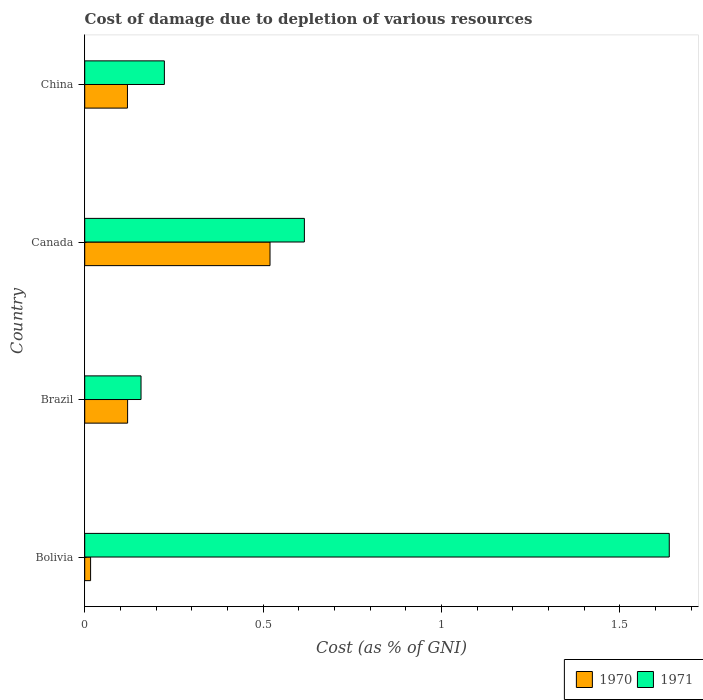How many different coloured bars are there?
Your response must be concise. 2. Are the number of bars per tick equal to the number of legend labels?
Keep it short and to the point. Yes. How many bars are there on the 2nd tick from the top?
Make the answer very short. 2. What is the cost of damage caused due to the depletion of various resources in 1971 in Brazil?
Provide a succinct answer. 0.16. Across all countries, what is the maximum cost of damage caused due to the depletion of various resources in 1970?
Your answer should be very brief. 0.52. Across all countries, what is the minimum cost of damage caused due to the depletion of various resources in 1971?
Offer a very short reply. 0.16. What is the total cost of damage caused due to the depletion of various resources in 1970 in the graph?
Offer a terse response. 0.78. What is the difference between the cost of damage caused due to the depletion of various resources in 1971 in Bolivia and that in China?
Provide a short and direct response. 1.42. What is the difference between the cost of damage caused due to the depletion of various resources in 1971 in China and the cost of damage caused due to the depletion of various resources in 1970 in Bolivia?
Give a very brief answer. 0.21. What is the average cost of damage caused due to the depletion of various resources in 1971 per country?
Make the answer very short. 0.66. What is the difference between the cost of damage caused due to the depletion of various resources in 1970 and cost of damage caused due to the depletion of various resources in 1971 in Brazil?
Your answer should be compact. -0.04. What is the ratio of the cost of damage caused due to the depletion of various resources in 1970 in Brazil to that in China?
Provide a succinct answer. 1. Is the cost of damage caused due to the depletion of various resources in 1971 in Bolivia less than that in China?
Make the answer very short. No. Is the difference between the cost of damage caused due to the depletion of various resources in 1970 in Bolivia and Brazil greater than the difference between the cost of damage caused due to the depletion of various resources in 1971 in Bolivia and Brazil?
Make the answer very short. No. What is the difference between the highest and the second highest cost of damage caused due to the depletion of various resources in 1970?
Your answer should be very brief. 0.4. What is the difference between the highest and the lowest cost of damage caused due to the depletion of various resources in 1971?
Provide a short and direct response. 1.48. What does the 2nd bar from the bottom in Brazil represents?
Keep it short and to the point. 1971. How many bars are there?
Your response must be concise. 8. What is the difference between two consecutive major ticks on the X-axis?
Keep it short and to the point. 0.5. Are the values on the major ticks of X-axis written in scientific E-notation?
Offer a terse response. No. How many legend labels are there?
Make the answer very short. 2. What is the title of the graph?
Keep it short and to the point. Cost of damage due to depletion of various resources. Does "1967" appear as one of the legend labels in the graph?
Ensure brevity in your answer.  No. What is the label or title of the X-axis?
Offer a terse response. Cost (as % of GNI). What is the label or title of the Y-axis?
Offer a terse response. Country. What is the Cost (as % of GNI) of 1970 in Bolivia?
Your answer should be very brief. 0.02. What is the Cost (as % of GNI) of 1971 in Bolivia?
Keep it short and to the point. 1.64. What is the Cost (as % of GNI) of 1970 in Brazil?
Provide a short and direct response. 0.12. What is the Cost (as % of GNI) of 1971 in Brazil?
Your answer should be compact. 0.16. What is the Cost (as % of GNI) of 1970 in Canada?
Your answer should be compact. 0.52. What is the Cost (as % of GNI) in 1971 in Canada?
Offer a very short reply. 0.62. What is the Cost (as % of GNI) in 1970 in China?
Give a very brief answer. 0.12. What is the Cost (as % of GNI) of 1971 in China?
Provide a succinct answer. 0.22. Across all countries, what is the maximum Cost (as % of GNI) of 1970?
Ensure brevity in your answer.  0.52. Across all countries, what is the maximum Cost (as % of GNI) of 1971?
Your response must be concise. 1.64. Across all countries, what is the minimum Cost (as % of GNI) in 1970?
Provide a short and direct response. 0.02. Across all countries, what is the minimum Cost (as % of GNI) in 1971?
Offer a very short reply. 0.16. What is the total Cost (as % of GNI) in 1970 in the graph?
Make the answer very short. 0.78. What is the total Cost (as % of GNI) of 1971 in the graph?
Offer a very short reply. 2.64. What is the difference between the Cost (as % of GNI) in 1970 in Bolivia and that in Brazil?
Your answer should be very brief. -0.1. What is the difference between the Cost (as % of GNI) in 1971 in Bolivia and that in Brazil?
Ensure brevity in your answer.  1.48. What is the difference between the Cost (as % of GNI) in 1970 in Bolivia and that in Canada?
Provide a short and direct response. -0.5. What is the difference between the Cost (as % of GNI) of 1971 in Bolivia and that in Canada?
Provide a short and direct response. 1.02. What is the difference between the Cost (as % of GNI) in 1970 in Bolivia and that in China?
Ensure brevity in your answer.  -0.1. What is the difference between the Cost (as % of GNI) of 1971 in Bolivia and that in China?
Your response must be concise. 1.42. What is the difference between the Cost (as % of GNI) of 1970 in Brazil and that in Canada?
Your answer should be very brief. -0.4. What is the difference between the Cost (as % of GNI) in 1971 in Brazil and that in Canada?
Give a very brief answer. -0.46. What is the difference between the Cost (as % of GNI) in 1970 in Brazil and that in China?
Your answer should be very brief. 0. What is the difference between the Cost (as % of GNI) of 1971 in Brazil and that in China?
Your answer should be very brief. -0.07. What is the difference between the Cost (as % of GNI) of 1970 in Canada and that in China?
Give a very brief answer. 0.4. What is the difference between the Cost (as % of GNI) of 1971 in Canada and that in China?
Keep it short and to the point. 0.39. What is the difference between the Cost (as % of GNI) of 1970 in Bolivia and the Cost (as % of GNI) of 1971 in Brazil?
Offer a terse response. -0.14. What is the difference between the Cost (as % of GNI) of 1970 in Bolivia and the Cost (as % of GNI) of 1971 in Canada?
Keep it short and to the point. -0.6. What is the difference between the Cost (as % of GNI) in 1970 in Bolivia and the Cost (as % of GNI) in 1971 in China?
Your answer should be compact. -0.21. What is the difference between the Cost (as % of GNI) in 1970 in Brazil and the Cost (as % of GNI) in 1971 in Canada?
Your response must be concise. -0.5. What is the difference between the Cost (as % of GNI) in 1970 in Brazil and the Cost (as % of GNI) in 1971 in China?
Give a very brief answer. -0.1. What is the difference between the Cost (as % of GNI) of 1970 in Canada and the Cost (as % of GNI) of 1971 in China?
Give a very brief answer. 0.3. What is the average Cost (as % of GNI) in 1970 per country?
Make the answer very short. 0.19. What is the average Cost (as % of GNI) in 1971 per country?
Your response must be concise. 0.66. What is the difference between the Cost (as % of GNI) in 1970 and Cost (as % of GNI) in 1971 in Bolivia?
Provide a succinct answer. -1.62. What is the difference between the Cost (as % of GNI) in 1970 and Cost (as % of GNI) in 1971 in Brazil?
Your response must be concise. -0.04. What is the difference between the Cost (as % of GNI) in 1970 and Cost (as % of GNI) in 1971 in Canada?
Keep it short and to the point. -0.1. What is the difference between the Cost (as % of GNI) in 1970 and Cost (as % of GNI) in 1971 in China?
Make the answer very short. -0.1. What is the ratio of the Cost (as % of GNI) of 1970 in Bolivia to that in Brazil?
Provide a short and direct response. 0.14. What is the ratio of the Cost (as % of GNI) in 1971 in Bolivia to that in Brazil?
Give a very brief answer. 10.38. What is the ratio of the Cost (as % of GNI) of 1970 in Bolivia to that in Canada?
Make the answer very short. 0.03. What is the ratio of the Cost (as % of GNI) of 1971 in Bolivia to that in Canada?
Make the answer very short. 2.66. What is the ratio of the Cost (as % of GNI) of 1970 in Bolivia to that in China?
Offer a very short reply. 0.14. What is the ratio of the Cost (as % of GNI) in 1971 in Bolivia to that in China?
Provide a succinct answer. 7.34. What is the ratio of the Cost (as % of GNI) in 1970 in Brazil to that in Canada?
Your response must be concise. 0.23. What is the ratio of the Cost (as % of GNI) of 1971 in Brazil to that in Canada?
Your answer should be very brief. 0.26. What is the ratio of the Cost (as % of GNI) in 1970 in Brazil to that in China?
Offer a terse response. 1. What is the ratio of the Cost (as % of GNI) of 1971 in Brazil to that in China?
Your answer should be very brief. 0.71. What is the ratio of the Cost (as % of GNI) in 1970 in Canada to that in China?
Offer a terse response. 4.34. What is the ratio of the Cost (as % of GNI) in 1971 in Canada to that in China?
Provide a succinct answer. 2.76. What is the difference between the highest and the second highest Cost (as % of GNI) of 1970?
Your response must be concise. 0.4. What is the difference between the highest and the lowest Cost (as % of GNI) in 1970?
Your answer should be compact. 0.5. What is the difference between the highest and the lowest Cost (as % of GNI) of 1971?
Make the answer very short. 1.48. 